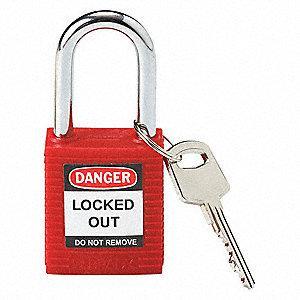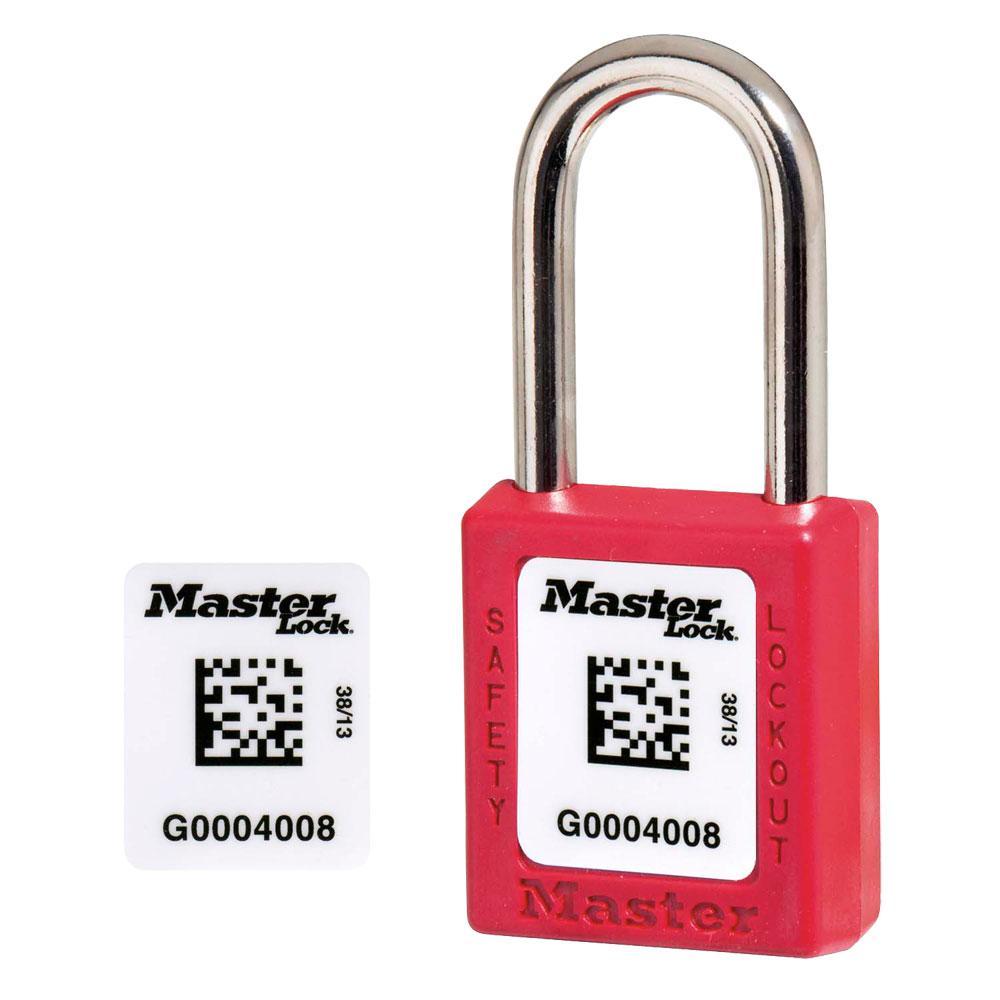The first image is the image on the left, the second image is the image on the right. Considering the images on both sides, is "Each image includes just one lock, and all locks have red bodies." valid? Answer yes or no. Yes. The first image is the image on the left, the second image is the image on the right. For the images shown, is this caption "Each image shows a red padlock, and in one image there is also one or more keys visible" true? Answer yes or no. Yes. 